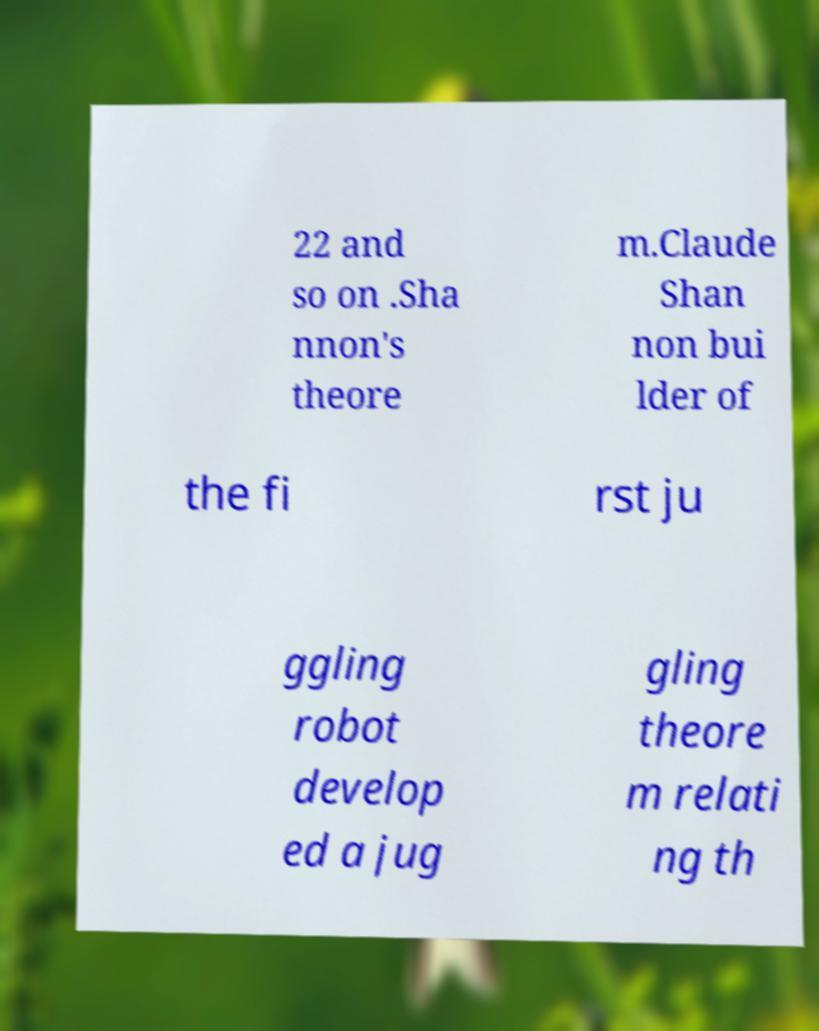What messages or text are displayed in this image? I need them in a readable, typed format. 22 and so on .Sha nnon's theore m.Claude Shan non bui lder of the fi rst ju ggling robot develop ed a jug gling theore m relati ng th 